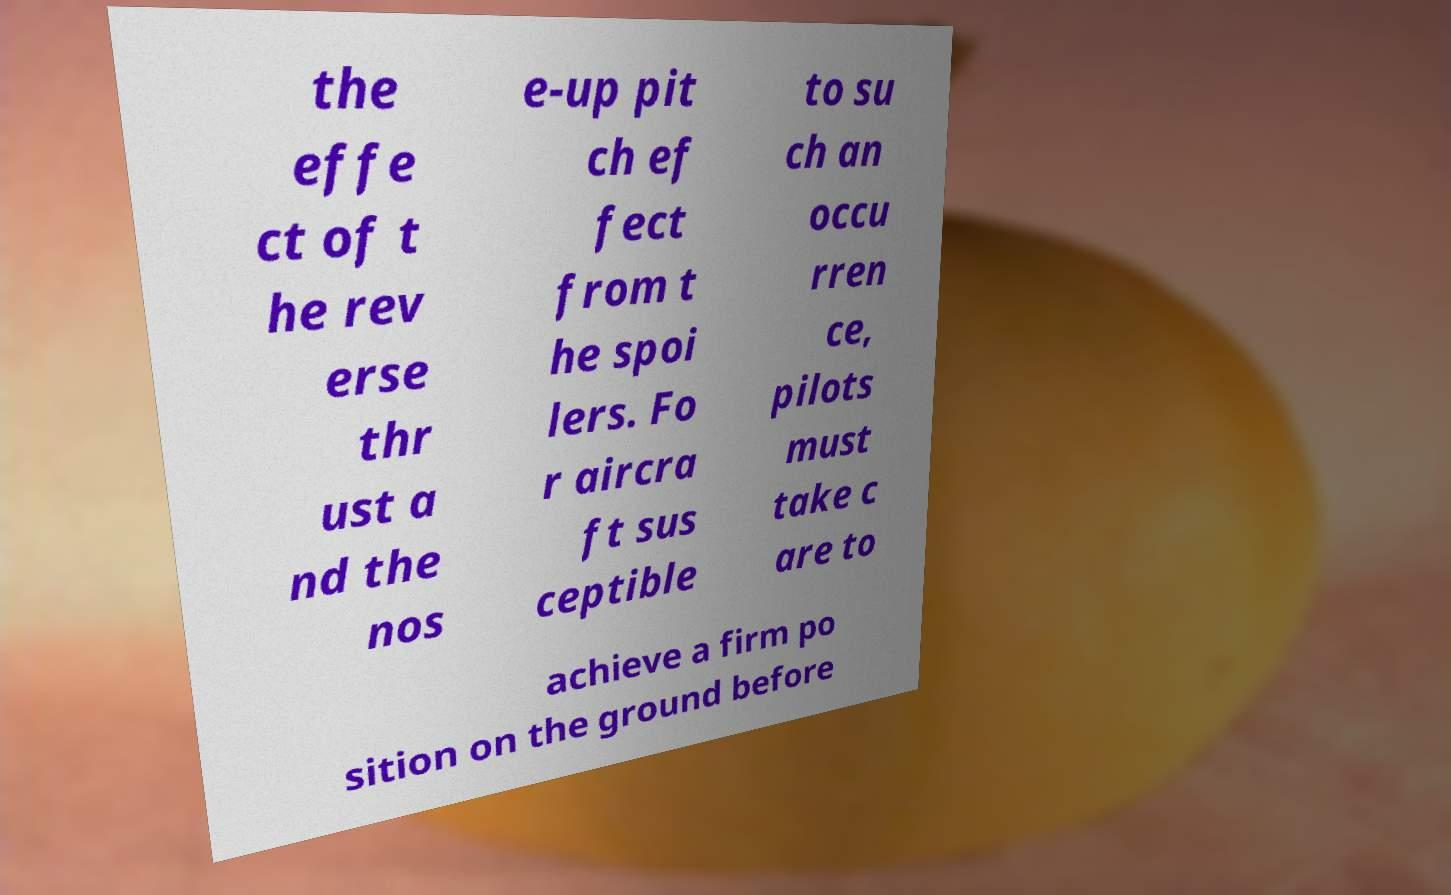Please read and relay the text visible in this image. What does it say? the effe ct of t he rev erse thr ust a nd the nos e-up pit ch ef fect from t he spoi lers. Fo r aircra ft sus ceptible to su ch an occu rren ce, pilots must take c are to achieve a firm po sition on the ground before 